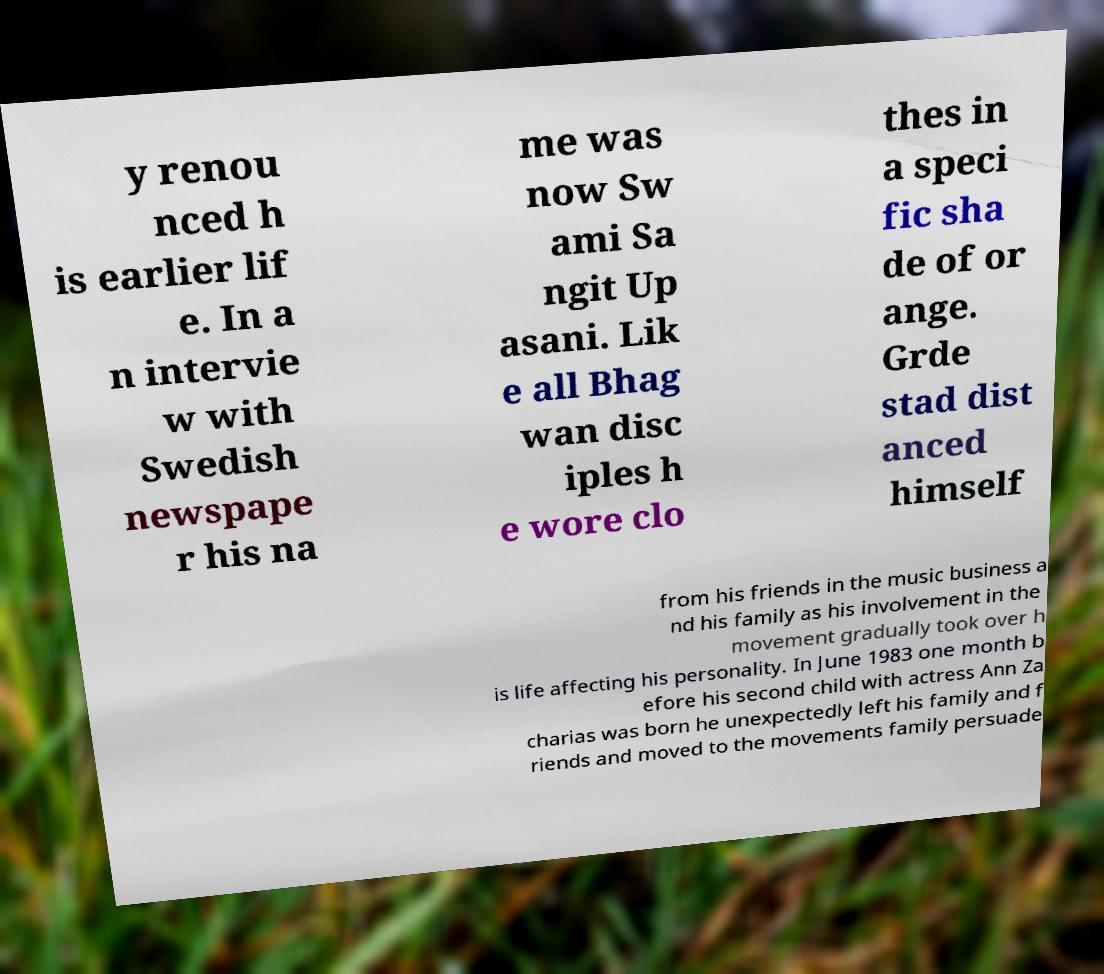There's text embedded in this image that I need extracted. Can you transcribe it verbatim? y renou nced h is earlier lif e. In a n intervie w with Swedish newspape r his na me was now Sw ami Sa ngit Up asani. Lik e all Bhag wan disc iples h e wore clo thes in a speci fic sha de of or ange. Grde stad dist anced himself from his friends in the music business a nd his family as his involvement in the movement gradually took over h is life affecting his personality. In June 1983 one month b efore his second child with actress Ann Za charias was born he unexpectedly left his family and f riends and moved to the movements family persuade 